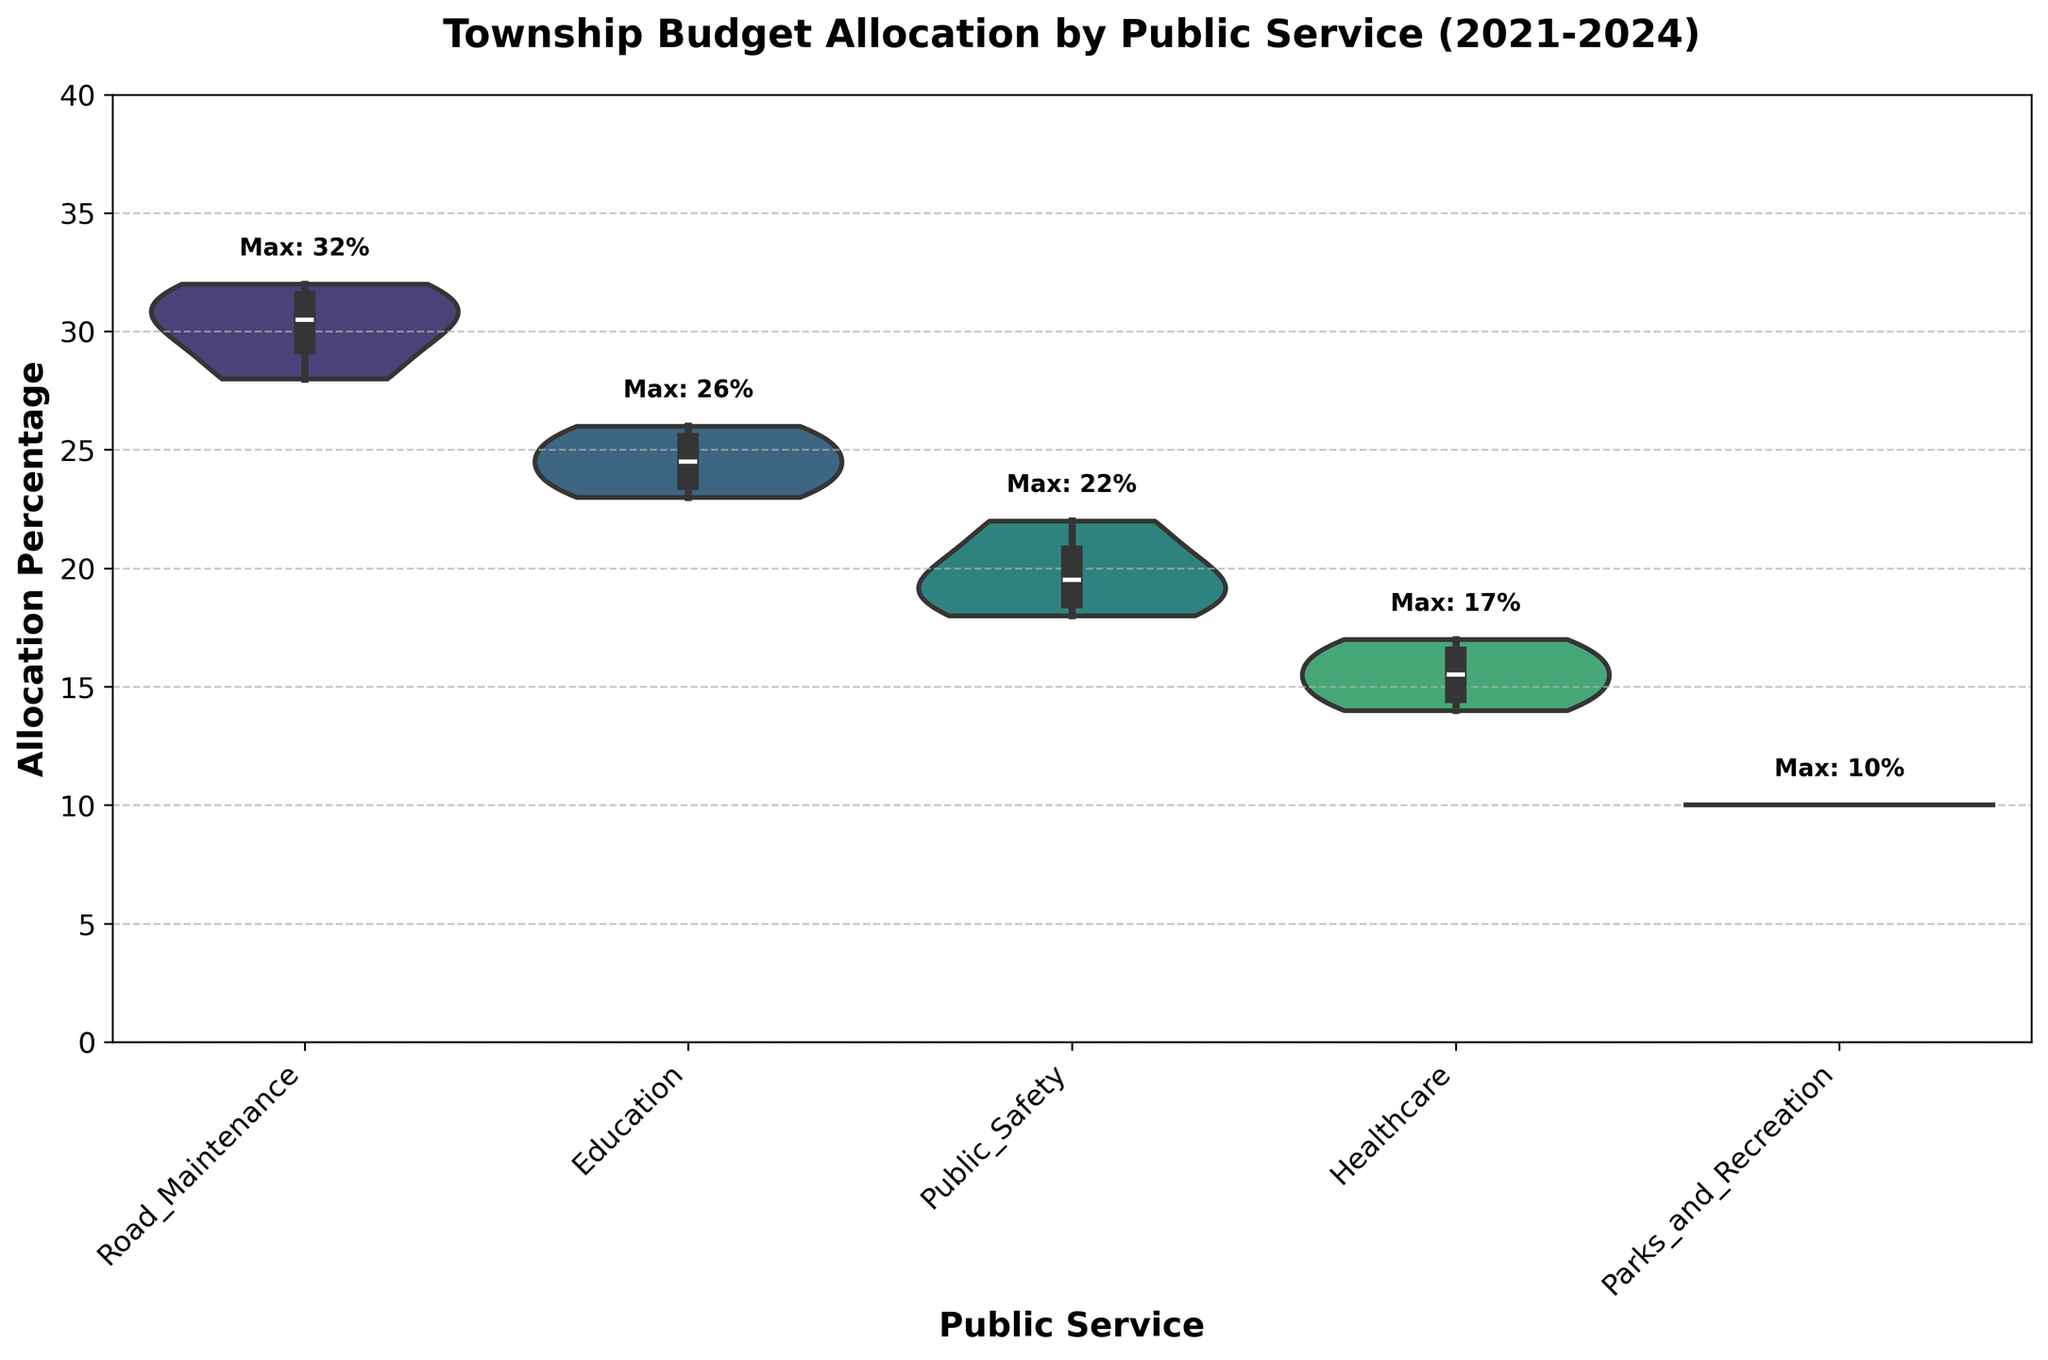What is the title of the figure? The title of a figure is usually displayed at the top of the chart for the viewer to understand what the chart is about. In this case, it is "Township Budget Allocation by Public Service (2021-2024)".
Answer: Township Budget Allocation by Public Service (2021-2024) What is the maximum allocation percentage for Education? To find the maximum allocation for Education, one would look at the label "Education" on the x-axis and then the highest point reached by the violins. According to the text annotations, the maximum is provided as "Max: 26%".
Answer: 26% Which public service shows the smallest range in allocation percentage? The range in allocation can be determined by the height and spread of the violin plot. Parks and Recreation has the smallest variation and limited height in its violin plot, indicating a consistent 10% allocation through the years.
Answer: Parks and Recreation Which year had the highest allocation percentage for Road Maintenance? To find the year with the highest allocation for Road Maintenance, one needs to identify the upper part of the Road Maintenance violin and the corresponding year. Here, the maximum value reads "Max: 32" which occurred in 2022 as indicated by the previous data.
Answer: 2022 How does the allocation for Healthcare in 2021 compare to 2024? To compare these two years, find the Healthcare violins and identify their topmost points for each year. In 2021, the allocation for Healthcare was 15%, while in 2024, it increased to 17%.
Answer: 17% is greater than 15% What is the median allocation for Public Safety? In a violin plot, the median is often indicated by the inner white dot or boxplot lines within the violin. For Public Safety, the middle line within the violin plot represents the median, likely around the central values close to 20%.
Answer: Approximately 20% Which public service had a decreasing trend in allocation percentages from 2021 to 2024? To identify a decreasing trend, one must compare the heights of the violins from 2021 to 2024 for each public service. Public Safety shows a reduction from 20% in 2021 to 19% in 2024.
Answer: Public Safety Considering the allocations, which public service received the most consistent budget allocation across the years? Consistency can be judged by the narrow shape of violins. Parks and Recreation’s violin remains narrow and centered at 10% throughout 2021-2024, indicating consistent allocation.
Answer: Parks and Recreation 